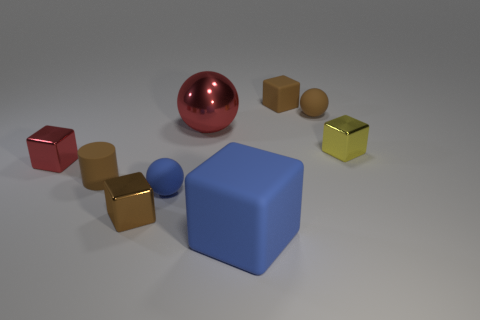Are there more small things that are on the left side of the brown shiny block than red things that are to the left of the small rubber cylinder?
Give a very brief answer. Yes. There is a brown thing that is both behind the cylinder and in front of the brown rubber block; what material is it made of?
Your answer should be compact. Rubber. What color is the big matte object that is the same shape as the tiny yellow metallic object?
Ensure brevity in your answer.  Blue. What size is the blue matte sphere?
Keep it short and to the point. Small. What color is the metal cube that is to the right of the matte block that is in front of the small brown metal thing?
Offer a very short reply. Yellow. What number of cubes are both in front of the metallic sphere and right of the big ball?
Give a very brief answer. 2. Are there more large matte blocks than blue metallic cubes?
Provide a short and direct response. Yes. What material is the tiny yellow cube?
Provide a succinct answer. Metal. There is a small block that is on the right side of the small matte block; what number of brown cubes are right of it?
Ensure brevity in your answer.  0. Do the cylinder and the rubber block on the left side of the tiny matte cube have the same color?
Your response must be concise. No. 